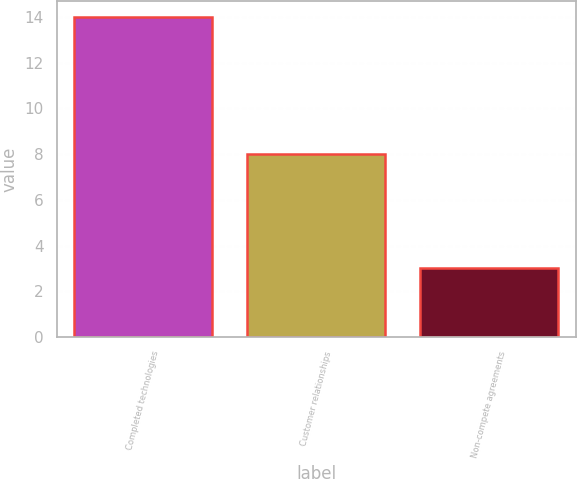Convert chart to OTSL. <chart><loc_0><loc_0><loc_500><loc_500><bar_chart><fcel>Completed technologies<fcel>Customer relationships<fcel>Non-compete agreements<nl><fcel>14<fcel>8<fcel>3<nl></chart> 